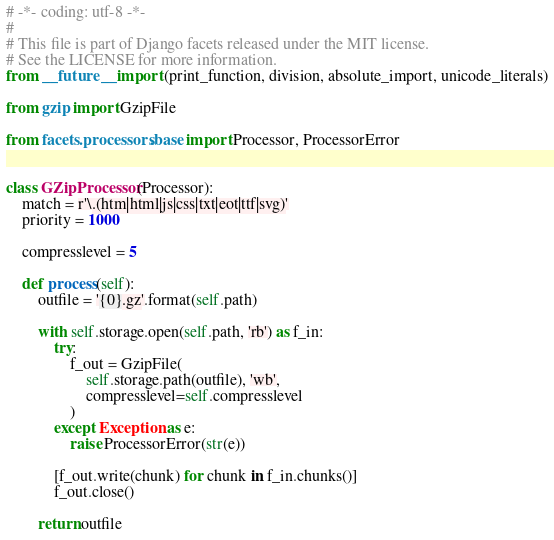Convert code to text. <code><loc_0><loc_0><loc_500><loc_500><_Python_># -*- coding: utf-8 -*-
#
# This file is part of Django facets released under the MIT license.
# See the LICENSE for more information.
from __future__ import (print_function, division, absolute_import, unicode_literals)

from gzip import GzipFile

from facets.processors.base import Processor, ProcessorError


class GZipProcessor(Processor):
    match = r'\.(htm|html|js|css|txt|eot|ttf|svg)'
    priority = 1000

    compresslevel = 5

    def process(self):
        outfile = '{0}.gz'.format(self.path)

        with self.storage.open(self.path, 'rb') as f_in:
            try:
                f_out = GzipFile(
                    self.storage.path(outfile), 'wb',
                    compresslevel=self.compresslevel
                )
            except Exception as e:
                raise ProcessorError(str(e))

            [f_out.write(chunk) for chunk in f_in.chunks()]
            f_out.close()

        return outfile
</code> 